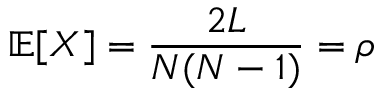<formula> <loc_0><loc_0><loc_500><loc_500>\mathbb { E } [ X ] = \frac { 2 L } { N ( N - 1 ) } = \rho</formula> 